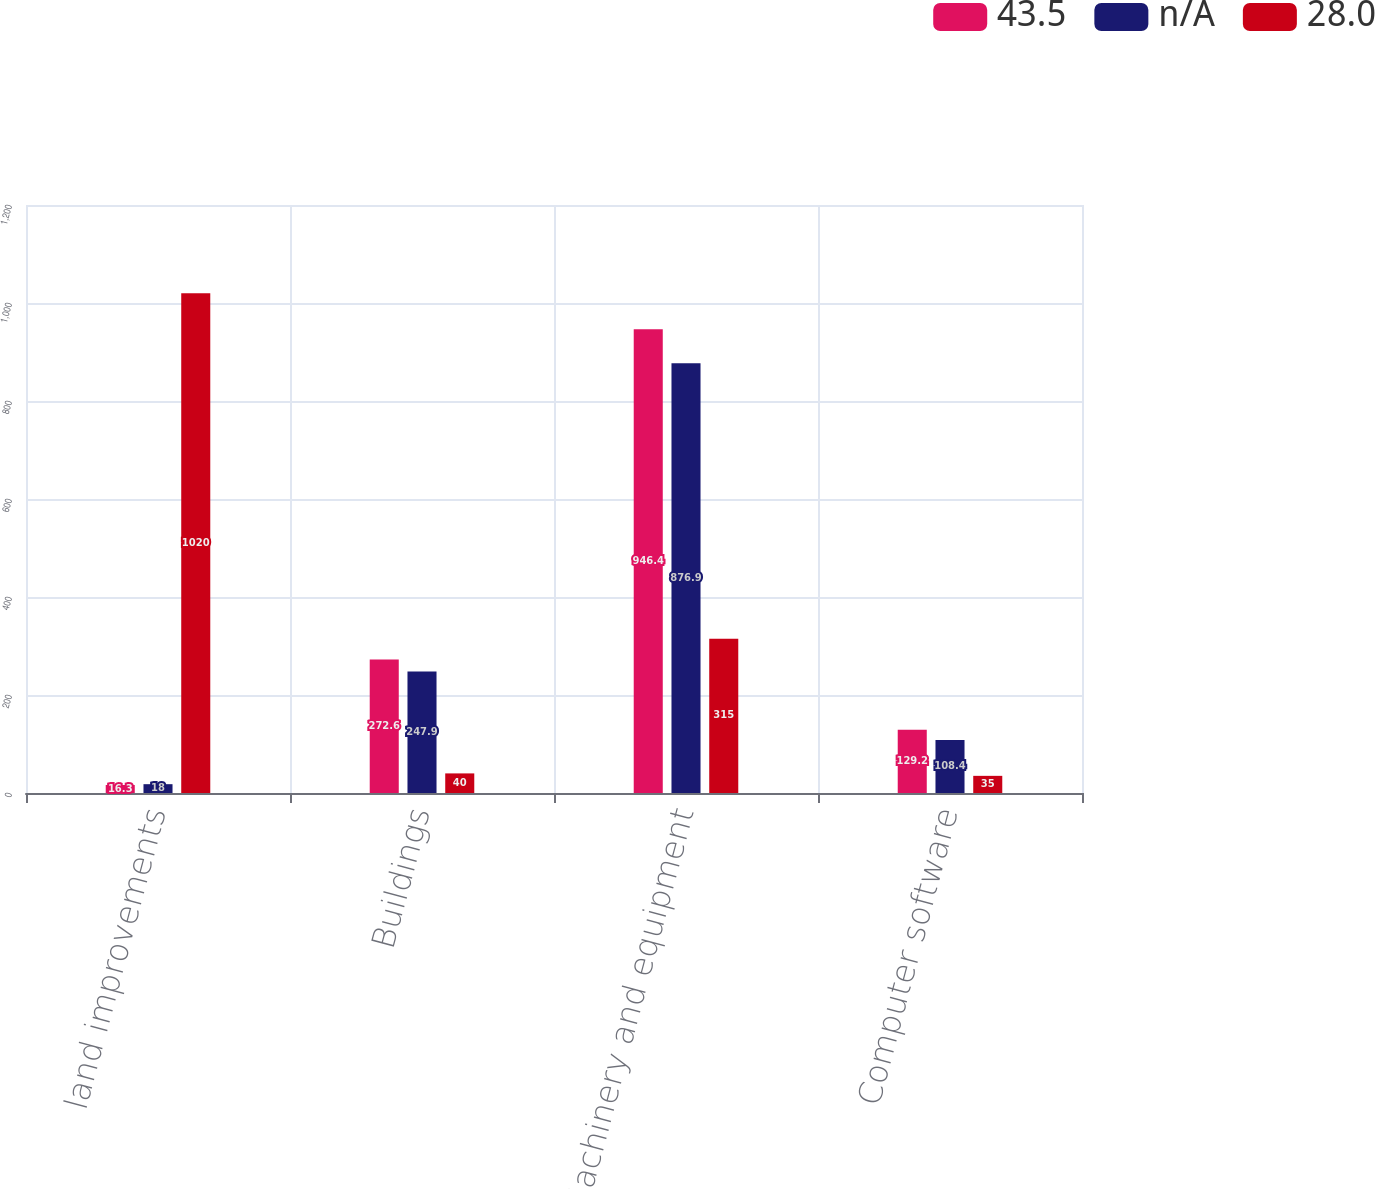Convert chart to OTSL. <chart><loc_0><loc_0><loc_500><loc_500><stacked_bar_chart><ecel><fcel>land improvements<fcel>Buildings<fcel>Machinery and equipment<fcel>Computer software<nl><fcel>43.5<fcel>16.3<fcel>272.6<fcel>946.4<fcel>129.2<nl><fcel>n/A<fcel>18<fcel>247.9<fcel>876.9<fcel>108.4<nl><fcel>28.0<fcel>1020<fcel>40<fcel>315<fcel>35<nl></chart> 